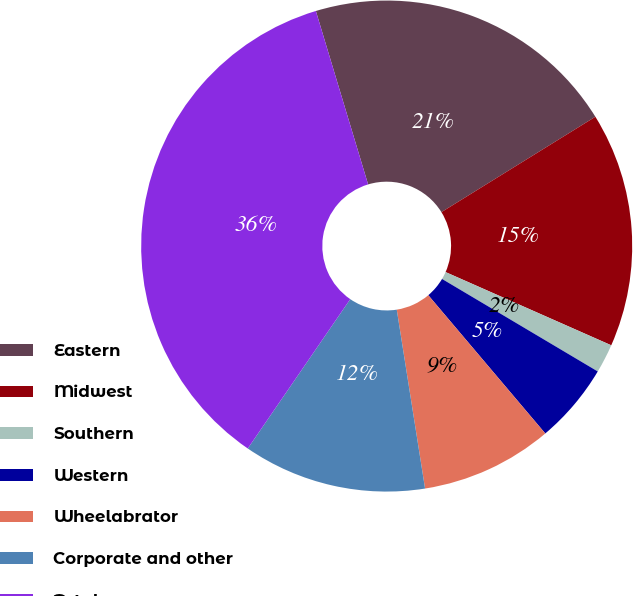Convert chart to OTSL. <chart><loc_0><loc_0><loc_500><loc_500><pie_chart><fcel>Eastern<fcel>Midwest<fcel>Southern<fcel>Western<fcel>Wheelabrator<fcel>Corporate and other<fcel>Total<nl><fcel>20.83%<fcel>15.45%<fcel>1.91%<fcel>5.29%<fcel>8.68%<fcel>12.07%<fcel>35.77%<nl></chart> 